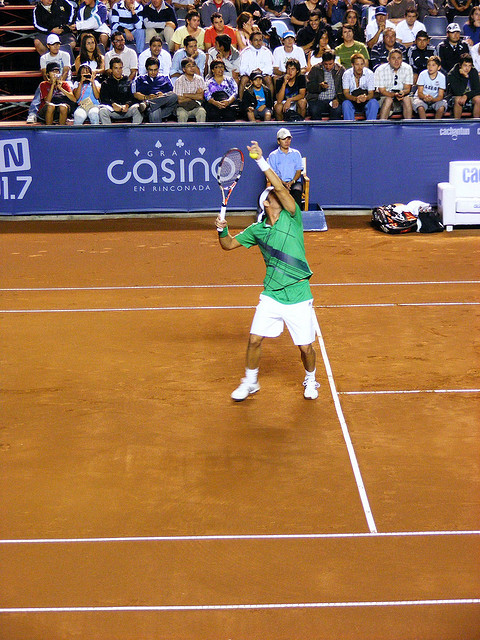Please identify all text content in this image. GRAN casino EN RICONADA EN RINCONADA GRAN N ca 1.7 